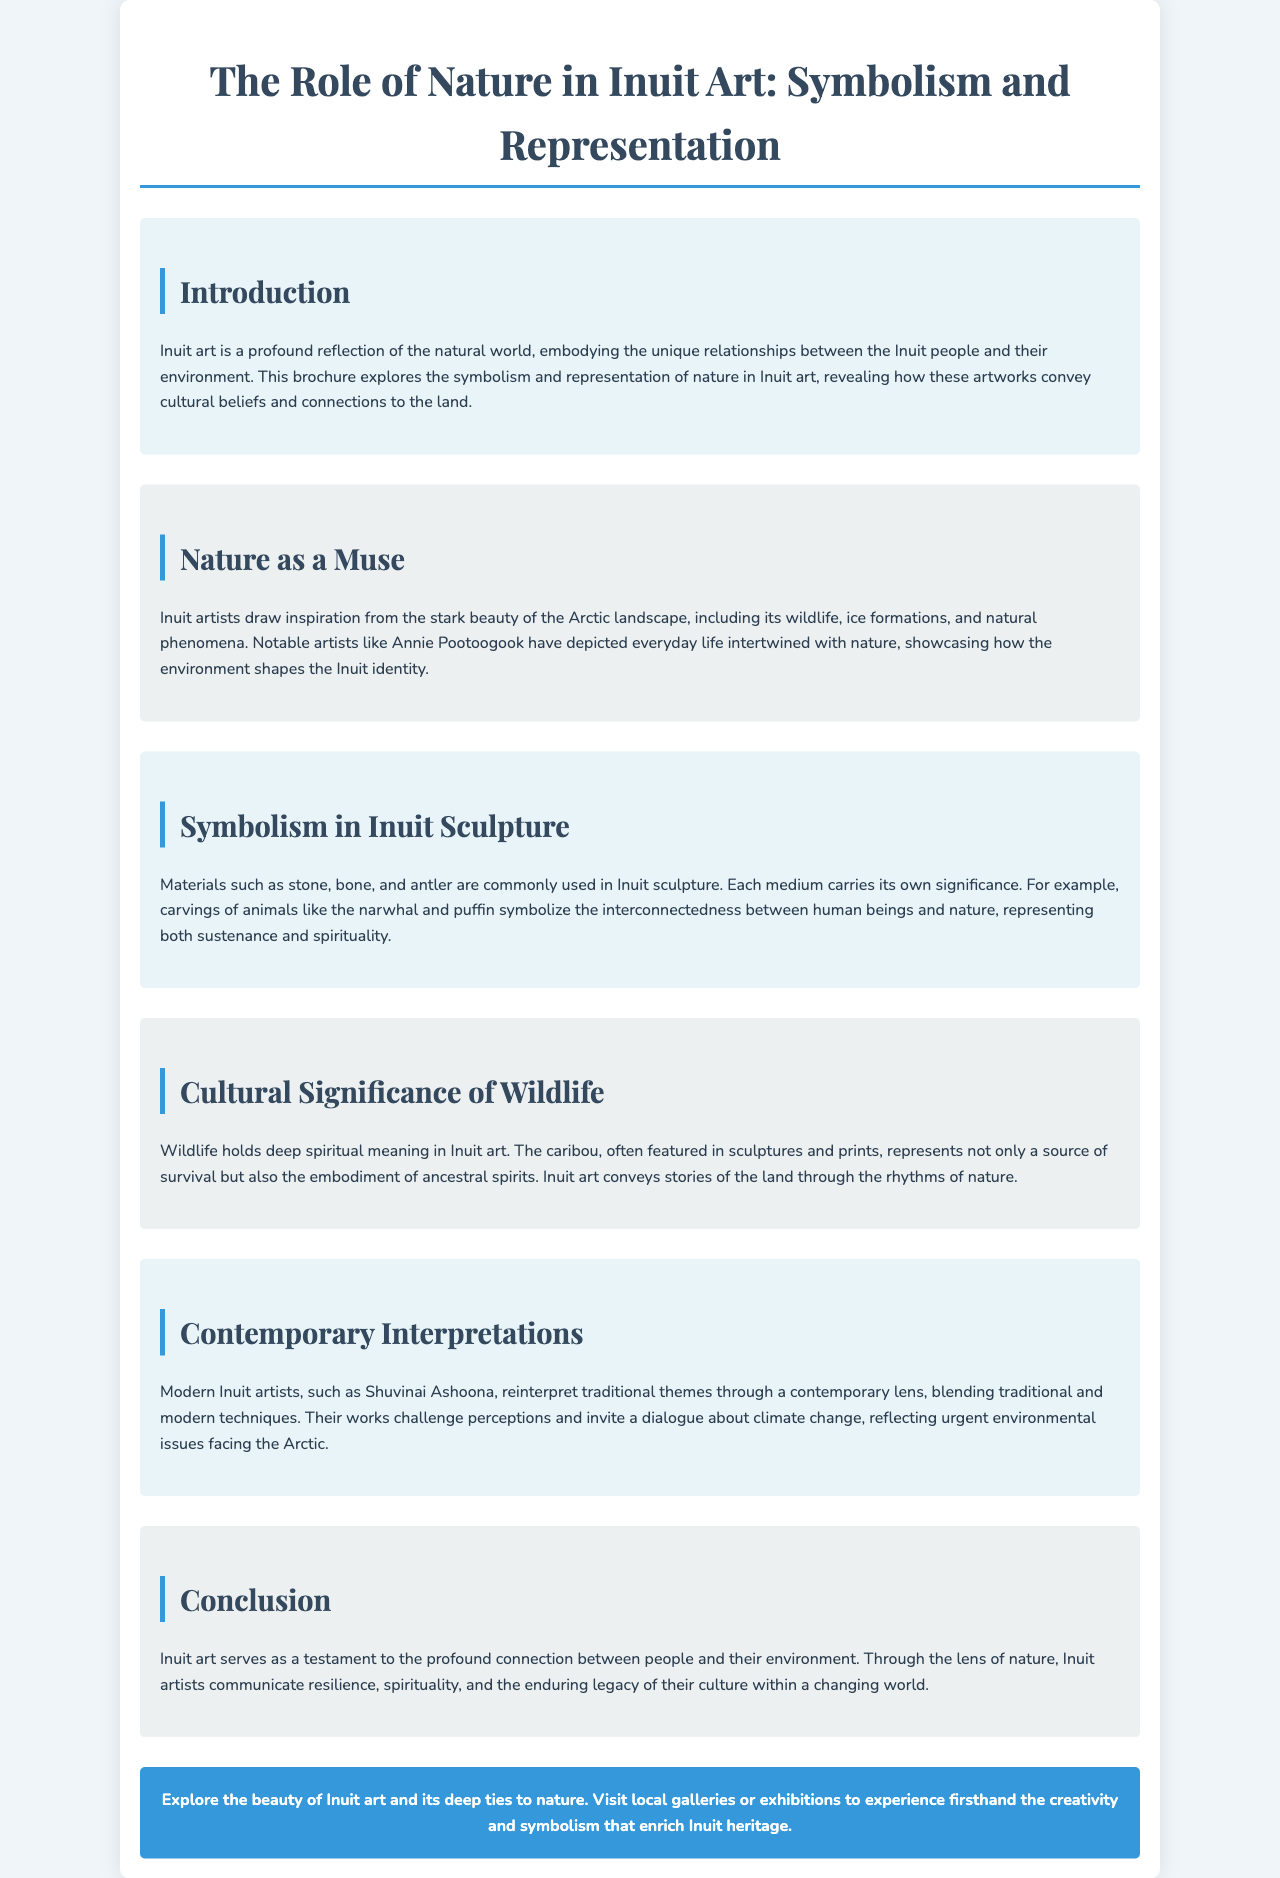What is the title of the brochure? The title of the brochure is stated prominently at the top, providing insight into its content.
Answer: The Role of Nature in Inuit Art: Symbolism and Representation Who is a notable Inuit artist mentioned in the document? The document mentions specific artists who have made significant contributions to Inuit art, highlighting their influence.
Answer: Annie Pootoogook What materials are commonly used in Inuit sculpture? The brochure discusses various materials used in sculpture and their significance, listing them explicitly.
Answer: Stone, bone, and antler Which animal represents both sustenance and spirituality in Inuit art? The brochure specifically identifies an animal that holds dual significance within Inuit culture and artworks.
Answer: Narwhal and puffin What does wildlife symbolize in Inuit art according to the brochure? The text describes the symbolic meanings embedded in wildlife representations in Inuit art, emphasizing a cultural aspect.
Answer: Spiritual meaning What contemporary issue do modern Inuit artists address in their works? The document discusses how contemporary artists reflect on modern challenges, including a pressing global concern.
Answer: Climate change What is the main theme conveyed in Inuit art? The brochure highlights a central theme related to human experiences and connections expressed through art.
Answer: Resilience, spirituality, and enduring legacy 